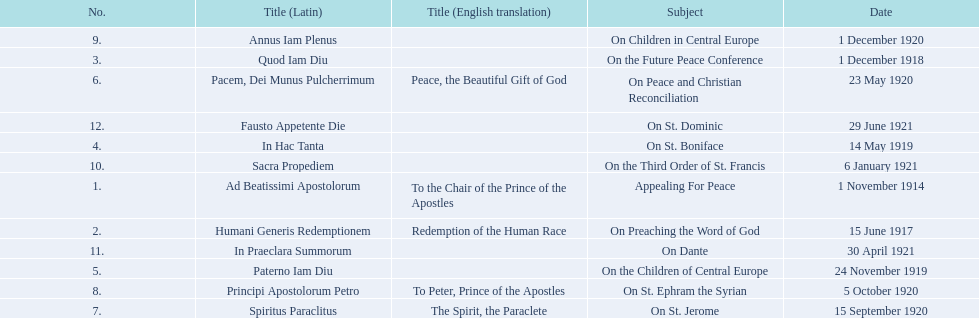What are all the subjects? Appealing For Peace, On Preaching the Word of God, On the Future Peace Conference, On St. Boniface, On the Children of Central Europe, On Peace and Christian Reconciliation, On St. Jerome, On St. Ephram the Syrian, On Children in Central Europe, On the Third Order of St. Francis, On Dante, On St. Dominic. Which occurred in 1920? On Peace and Christian Reconciliation, On St. Jerome, On St. Ephram the Syrian, On Children in Central Europe. Which occurred in may of that year? On Peace and Christian Reconciliation. 